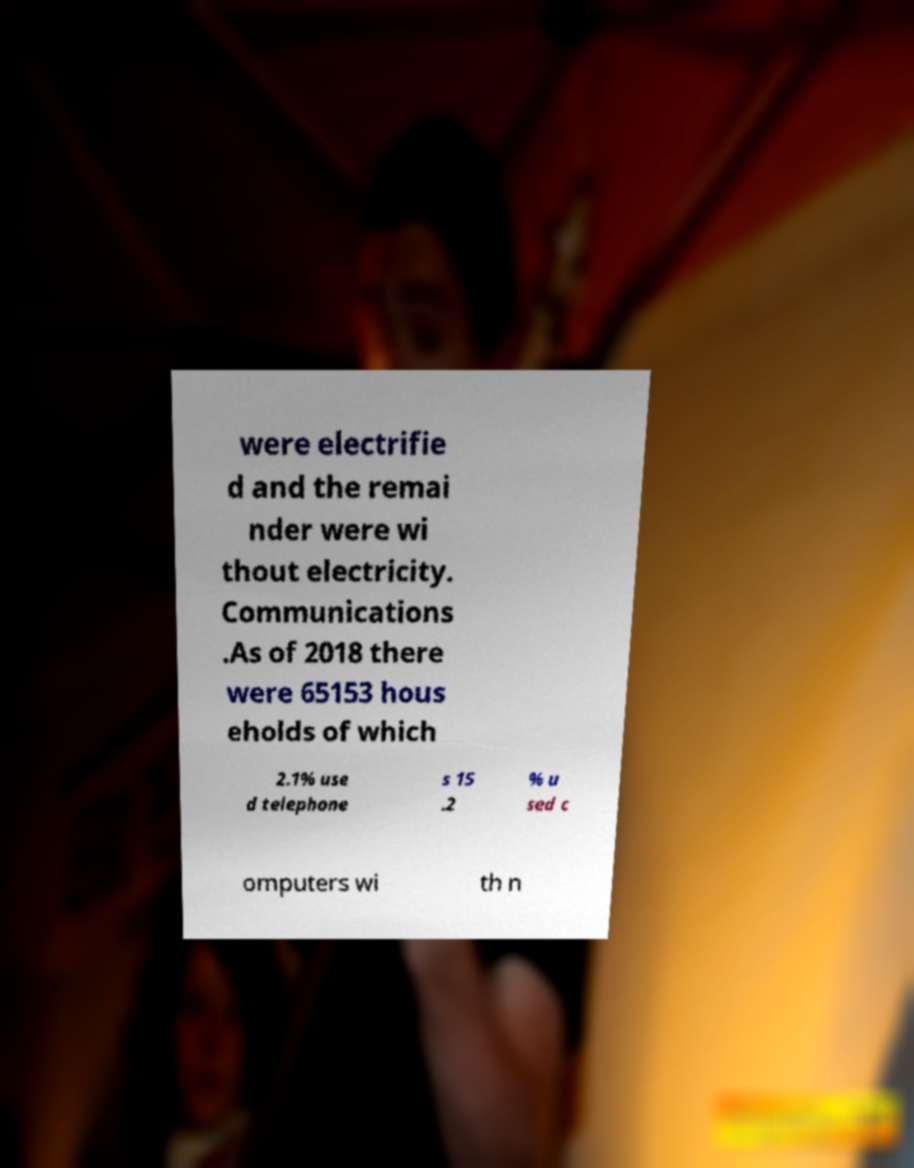Can you read and provide the text displayed in the image?This photo seems to have some interesting text. Can you extract and type it out for me? were electrifie d and the remai nder were wi thout electricity. Communications .As of 2018 there were 65153 hous eholds of which 2.1% use d telephone s 15 .2 % u sed c omputers wi th n 